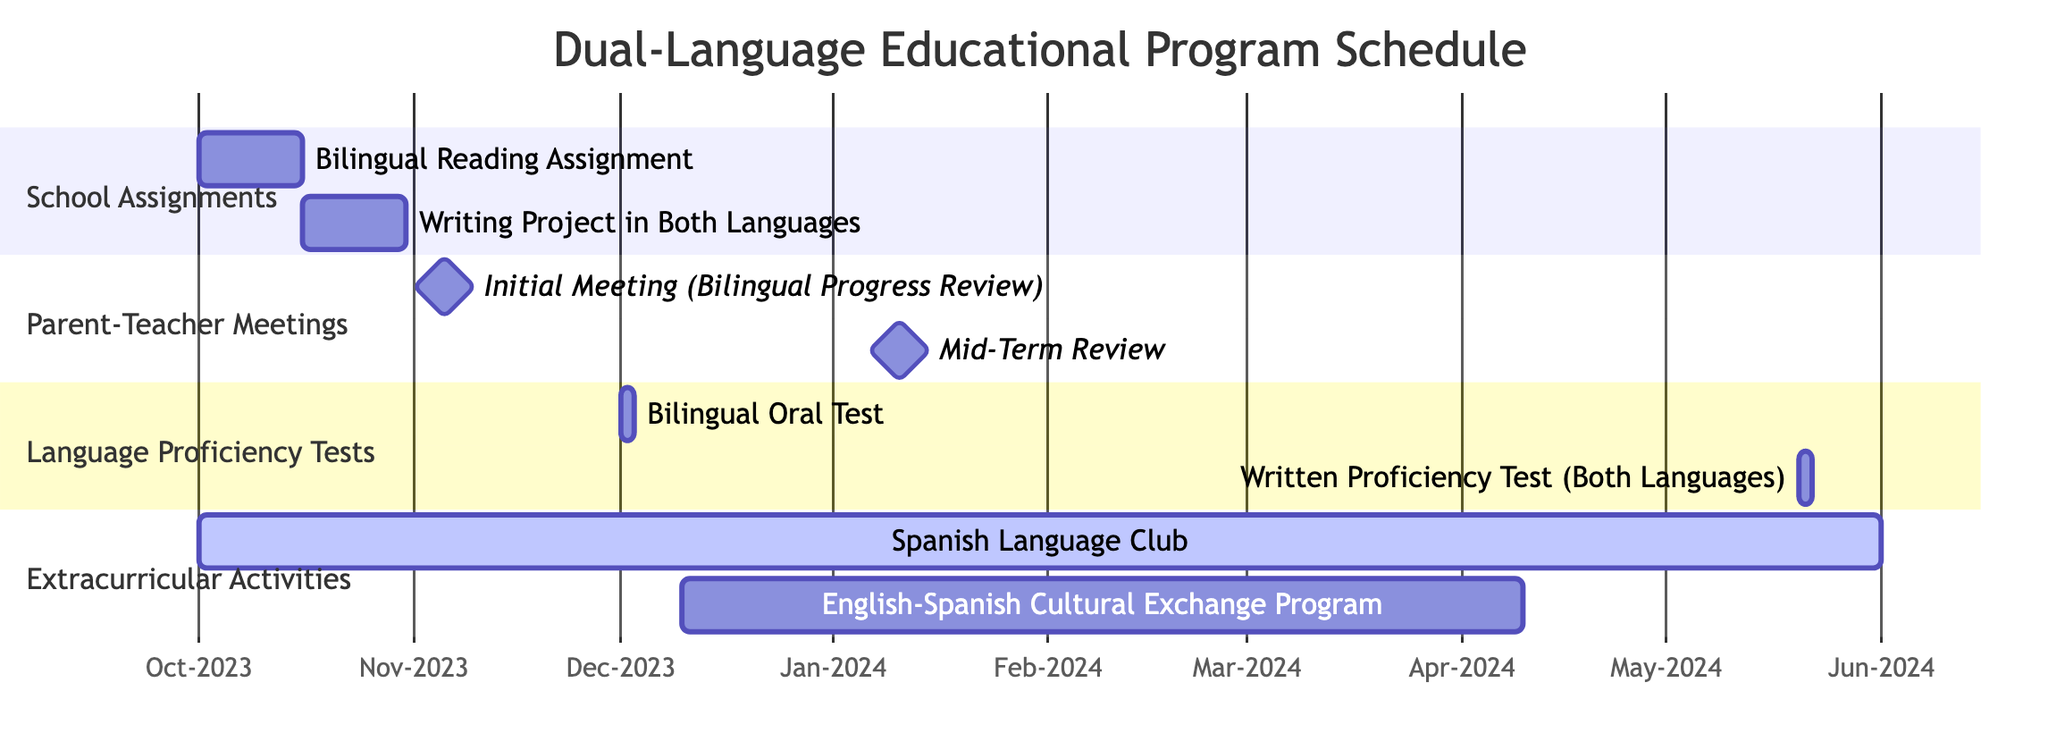What is the total number of tasks in the diagram? The diagram consists of four main tasks: School Assignments, Parent-Teacher Meetings, Language Proficiency Tests, and Extracurricular Activities. Each of these tasks contains its own subtasks. Counting these, we find there are a total of 6 subtasks and 4 main tasks, giving a total of 10 tasks overall.
Answer: 10 When does the Spanish Language Club start? The Spanish Language Club is scheduled to start on October 1, 2023, as indicated in the Extracurricular Activities section of the diagram.
Answer: October 1, 2023 Which task has a milestone in November? The Parent-Teacher Meetings task has a milestone on November 5, 2023, specifically for the Initial Meeting (Bilingual Progress Review). This is the only milestone occurring in that month.
Answer: Parent-Teacher Meetings What are the end dates for the writing project? The Writing Project in Both Languages ends on October 30, 2023, which is clearly indicated in the School Assignments section of the diagram.
Answer: October 30, 2023 How many days does the Bilingual Oral Test last? The Bilingual Oral Test lasts 2 days, as specified in the Language Proficiency Tests section, starting on December 1, 2023, and ending on December 2, 2023.
Answer: 2 days What is the earliest start date of any task in the diagram? The earliest start date of any task is October 1, 2023, which applies to both the Bilingual Reading Assignment and the Spanish Language Club, both starting on that date.
Answer: October 1, 2023 Which task has a longer duration: Writing Project in Both Languages or the English-Spanish Cultural Exchange Program? The Writing Project in Both Languages lasts for 15 days (from October 16 to October 30), while the English-Spanish Cultural Exchange Program spans 4 months (from December 10, 2023, to April 10, 2024). Therefore, the English-Spanish Cultural Exchange Program has a longer duration.
Answer: English-Spanish Cultural Exchange Program What is the last event listed in the diagram? The last event listed in the diagram is the Written Proficiency Test (Both Languages), which ends on May 21, 2024, making it the final task in the schedule.
Answer: Written Proficiency Test (Both Languages) 